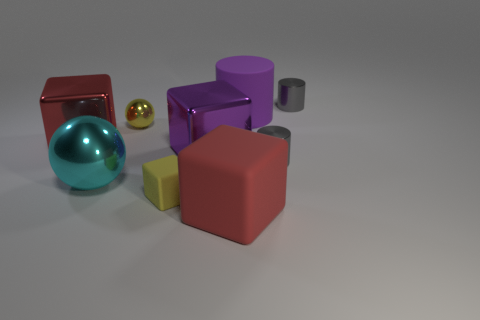The small shiny cylinder that is behind the yellow ball is what color?
Your answer should be very brief. Gray. Is the size of the yellow object in front of the cyan metal sphere the same as the red cube behind the cyan metallic object?
Make the answer very short. No. What number of things are either large cyan balls or small cyan blocks?
Give a very brief answer. 1. What material is the tiny gray cylinder in front of the purple object that is in front of the yellow ball made of?
Ensure brevity in your answer.  Metal. What number of red shiny things are the same shape as the cyan metal thing?
Offer a terse response. 0. Are there any big objects of the same color as the tiny shiny ball?
Offer a very short reply. No. How many things are small yellow objects in front of the big red shiny object or red cubes on the right side of the tiny yellow rubber block?
Make the answer very short. 2. There is a gray cylinder in front of the matte cylinder; is there a yellow metallic object in front of it?
Keep it short and to the point. No. There is a red rubber thing that is the same size as the purple rubber thing; what is its shape?
Make the answer very short. Cube. How many objects are either gray things that are behind the red metallic block or gray metallic things?
Provide a short and direct response. 2. 